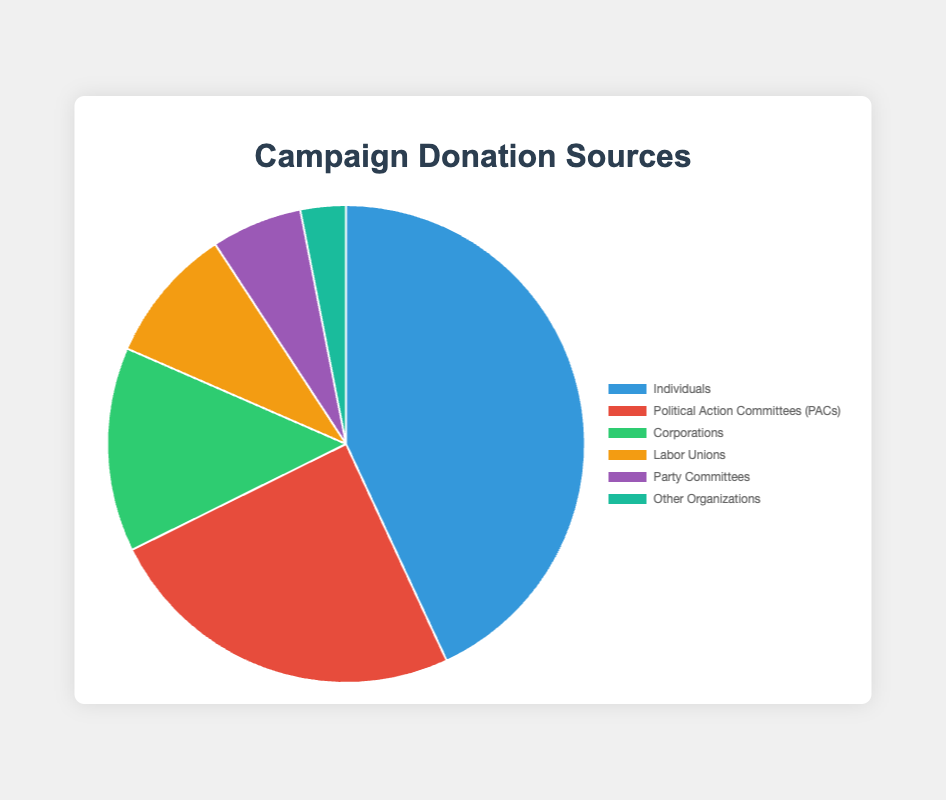What is the percentage contribution of donations from Individuals? To find the percentage, divide the donation amount from Individuals by the total donation amount and multiply by 100. Total donations = 5600000 + 3200000 + 1800000 + 1200000 + 800000 + 400000 = 13000000. Percentage = (5600000 / 13000000) * 100 = 43.1%
Answer: 43.1% Which source has the lowest contribution? By examining the data, the donation amounts are as follows: Individuals - 5600000, PACs - 3200000, Corporations - 1800000, Labor Unions - 1200000, Party Committees - 800000, Other Organizations - 400000. The lowest amount is 400000 from Other Organizations.
Answer: Other Organizations What is the total amount of donations from PACs and Corporations? Add the amounts from PACs and Corporations: 3200000 + 1800000 = 5000000
Answer: 5000000 How does the contribution from Labor Unions compare to that from Corporations? By comparing the amounts, Labor Unions contribute 1200000 and Corporations contribute 1800000. 1200000 is less than 1800000.
Answer: Less than What fraction of the total donations do PACs contribute? Calculate the fraction by dividing PACs' donation by the total donation amount. Total donations = 13000000. Fraction = 3200000 / 13000000 = 0.246 or roughly 1/4.
Answer: 1/4 Which sources exceed $1,000,000 in donations? By examining the data, the sources exceeding $1,000,000 are Individuals (5600000), PACs (3200000), Corporations (1800000), and Labor Unions (1200000).
Answer: Individuals, PACs, Corporations, and Labor Unions How much more did Individuals donate compared to Corporations? Subtract the amount donated by Corporations from the amount donated by Individuals: 5600000 - 1800000 = 3800000
Answer: 3800000 Which color represents the donations from Party Committees? According to the provided color scheme in the code, the color representing Party Committees is purple.
Answer: Purple What is the combined total of donations from Other Organizations and Party Committees? Add the amounts from Other Organizations and Party Committees: 400000 + 800000 = 1200000
Answer: 1200000 What is the average donation amount across all sources? Compute the total donations and divide by the number of sources. Total = 13000000. Number of sources = 6. Average = 13000000 / 6 = 2166666.67
Answer: 2166666.67 